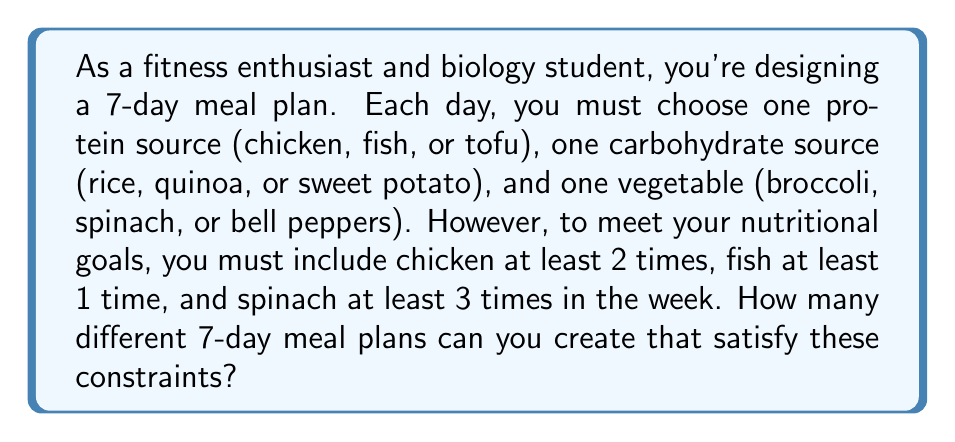What is the answer to this math problem? Let's approach this problem step-by-step:

1) First, we need to consider the minimum requirements:
   - Chicken: 2 times
   - Fish: 1 time
   - Spinach: 3 times

2) This leaves us with 4 days where we have more flexibility:
   7 - (2 + 1) = 4 days for protein choices
   7 - 3 = 4 days for vegetable choices

3) Let's count the number of ways to arrange the proteins:
   - We need to choose 4 days out of 7 for the flexible protein slots: $\binom{7}{4}$
   - For these 4 days, we have 3 choices each (chicken, fish, or tofu): $3^4$

4) For vegetables:
   - We need to choose 4 days out of 7 for the flexible vegetable slots: $\binom{7}{4}$
   - For these 4 days, we have 3 choices each (broccoli, spinach, or bell peppers): $3^4$

5) For carbohydrates, we have 3 choices for all 7 days: $3^7$

6) By the multiplication principle, the total number of meal plans is:

   $$\binom{7}{4} \cdot 3^4 \cdot \binom{7}{4} \cdot 3^4 \cdot 3^7$$

7) Calculating:
   $$35 \cdot 81 \cdot 35 \cdot 81 \cdot 2187 = 17,006,112,000$$
Answer: 17,006,112,000 different meal plans 